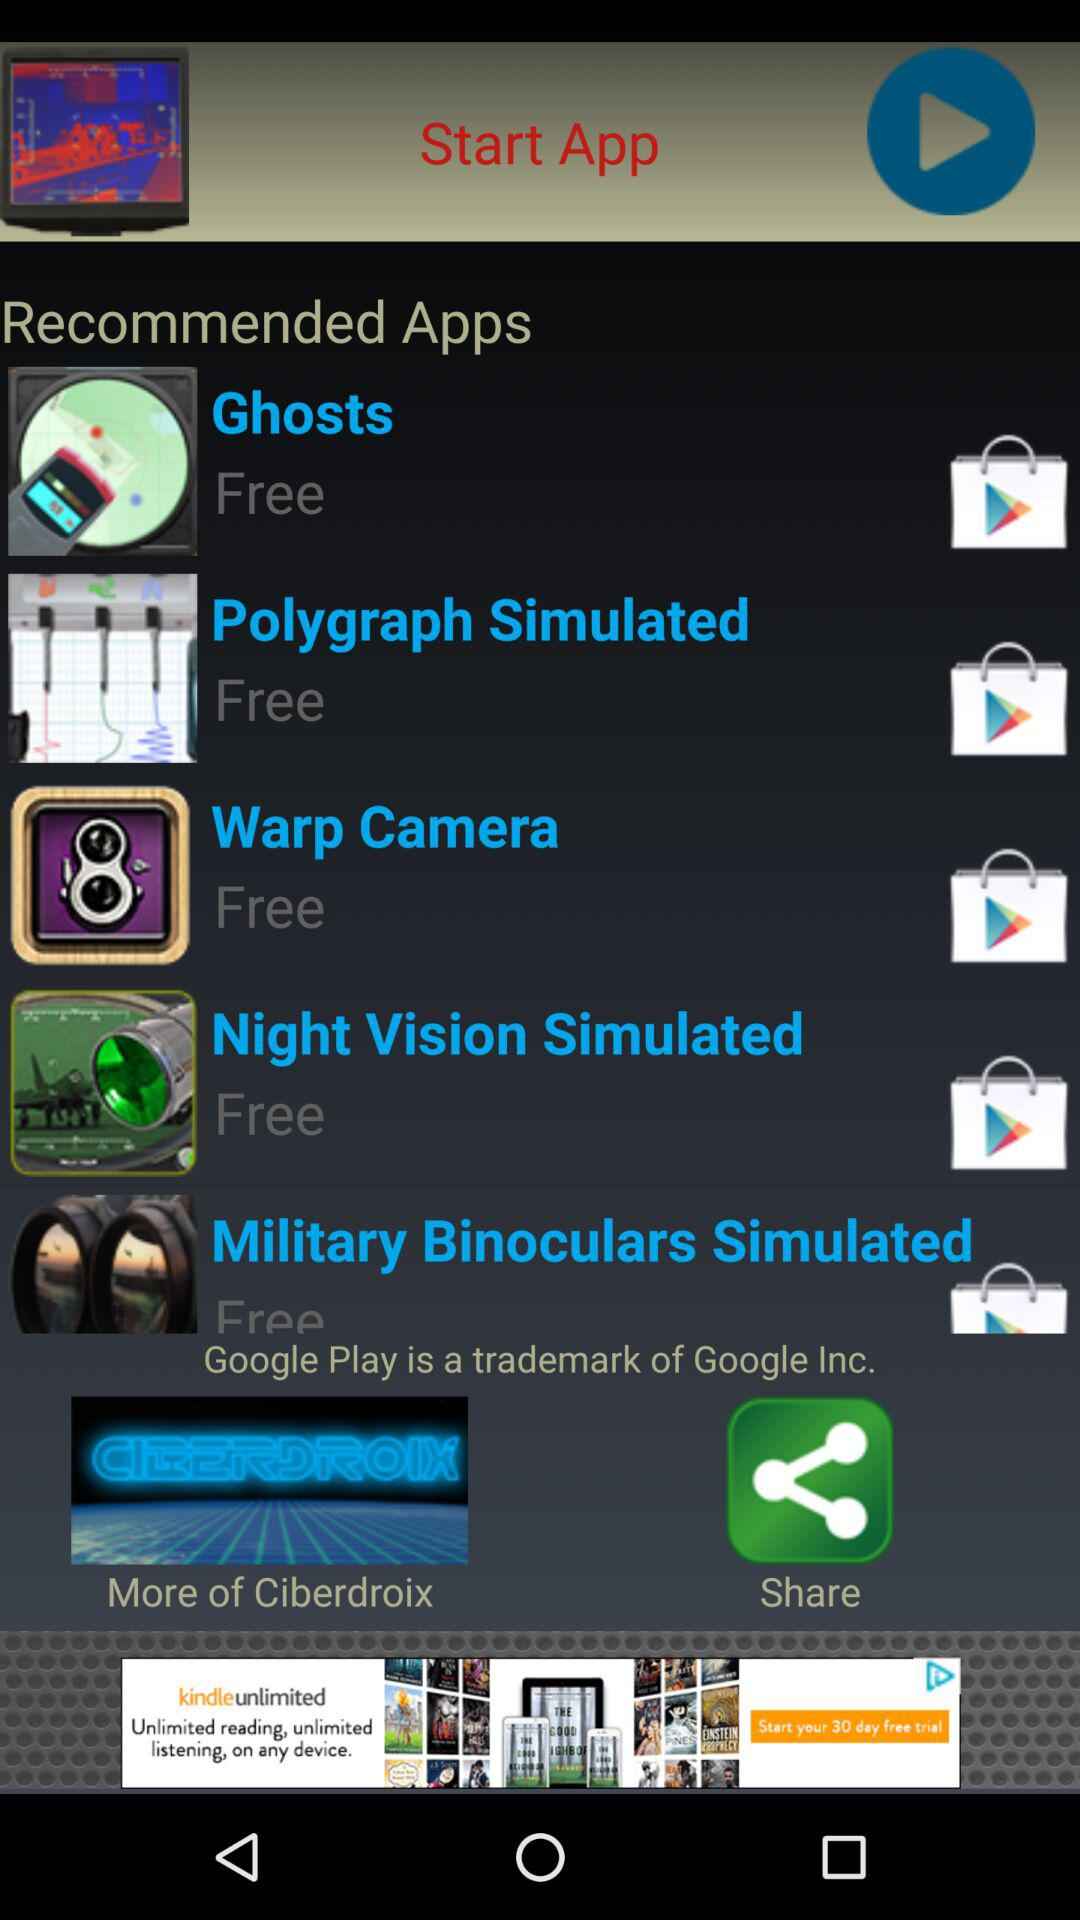How many items are free?
Answer the question using a single word or phrase. 5 